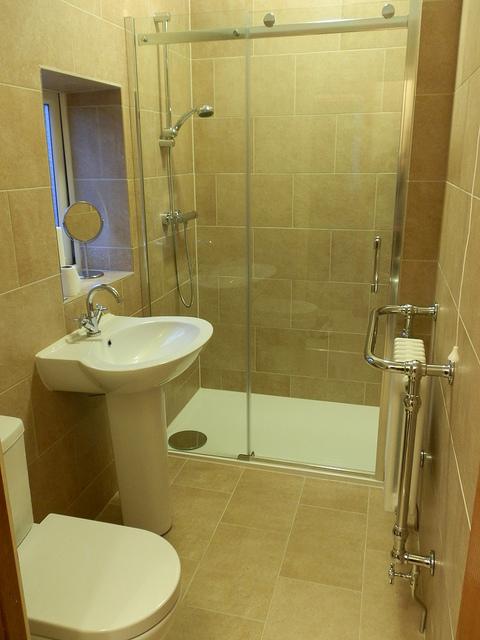Is this a public restroom?
Concise answer only. No. What type of bathtub is that?
Answer briefly. Shower. Is the water running in the shower?
Concise answer only. No. What color is the sink?
Answer briefly. White. Which room of the house is this?
Write a very short answer. Bathroom. 